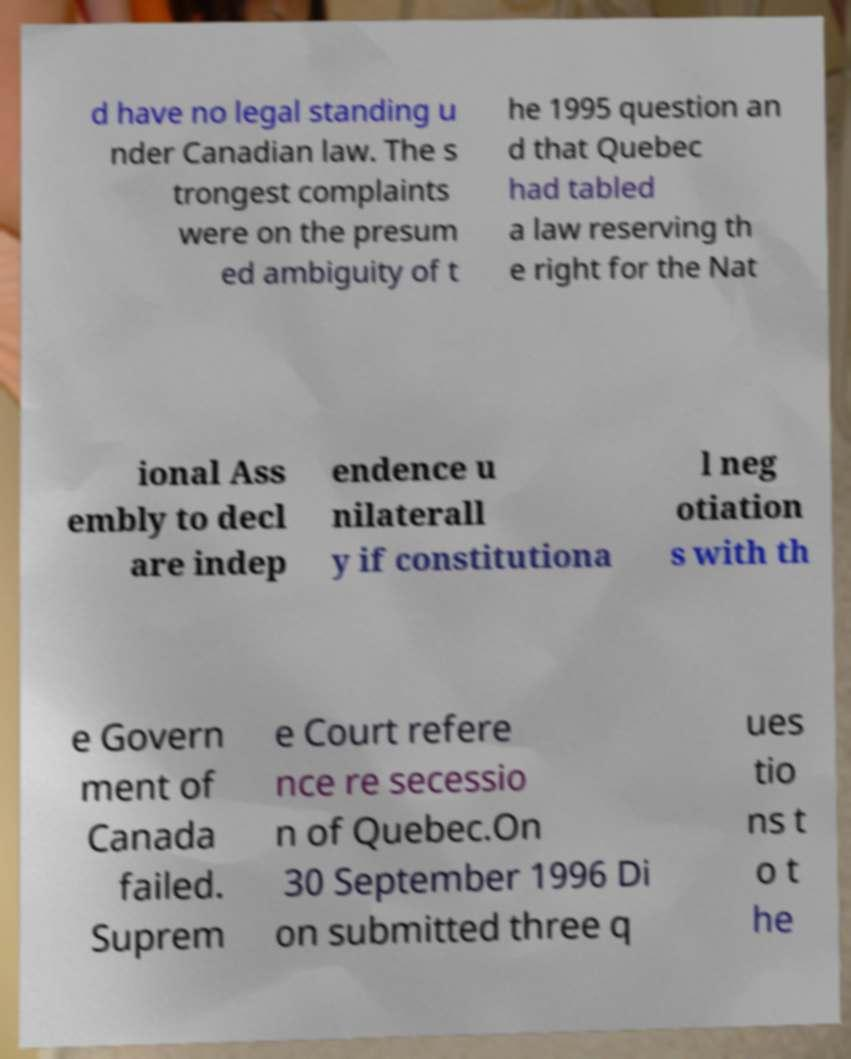Please identify and transcribe the text found in this image. d have no legal standing u nder Canadian law. The s trongest complaints were on the presum ed ambiguity of t he 1995 question an d that Quebec had tabled a law reserving th e right for the Nat ional Ass embly to decl are indep endence u nilaterall y if constitutiona l neg otiation s with th e Govern ment of Canada failed. Suprem e Court refere nce re secessio n of Quebec.On 30 September 1996 Di on submitted three q ues tio ns t o t he 